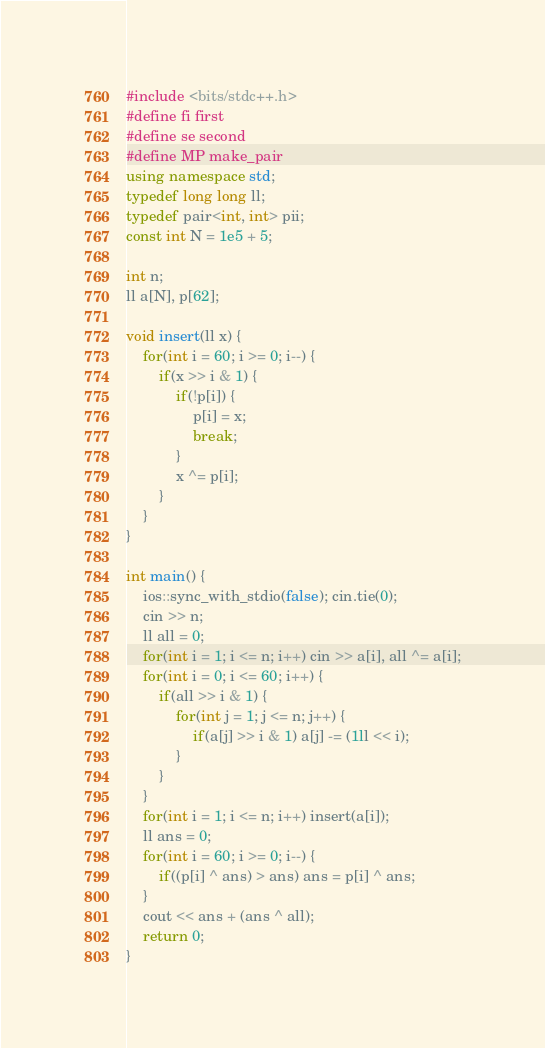Convert code to text. <code><loc_0><loc_0><loc_500><loc_500><_C++_>#include <bits/stdc++.h>
#define fi first
#define se second
#define MP make_pair
using namespace std;
typedef long long ll;
typedef pair<int, int> pii;
const int N = 1e5 + 5;
 
int n;
ll a[N], p[62];
 
void insert(ll x) {
    for(int i = 60; i >= 0; i--) {
        if(x >> i & 1) {
            if(!p[i]) {
                p[i] = x;
                break;
            }
            x ^= p[i];
        }
    }
}
 
int main() {
    ios::sync_with_stdio(false); cin.tie(0);
    cin >> n;
    ll all = 0;
    for(int i = 1; i <= n; i++) cin >> a[i], all ^= a[i];
    for(int i = 0; i <= 60; i++) {
        if(all >> i & 1) {
            for(int j = 1; j <= n; j++) {
                if(a[j] >> i & 1) a[j] -= (1ll << i);
            }
        }
    }
    for(int i = 1; i <= n; i++) insert(a[i]);
    ll ans = 0;
    for(int i = 60; i >= 0; i--) {
        if((p[i] ^ ans) > ans) ans = p[i] ^ ans;
    }
    cout << ans + (ans ^ all);
    return 0;
}</code> 